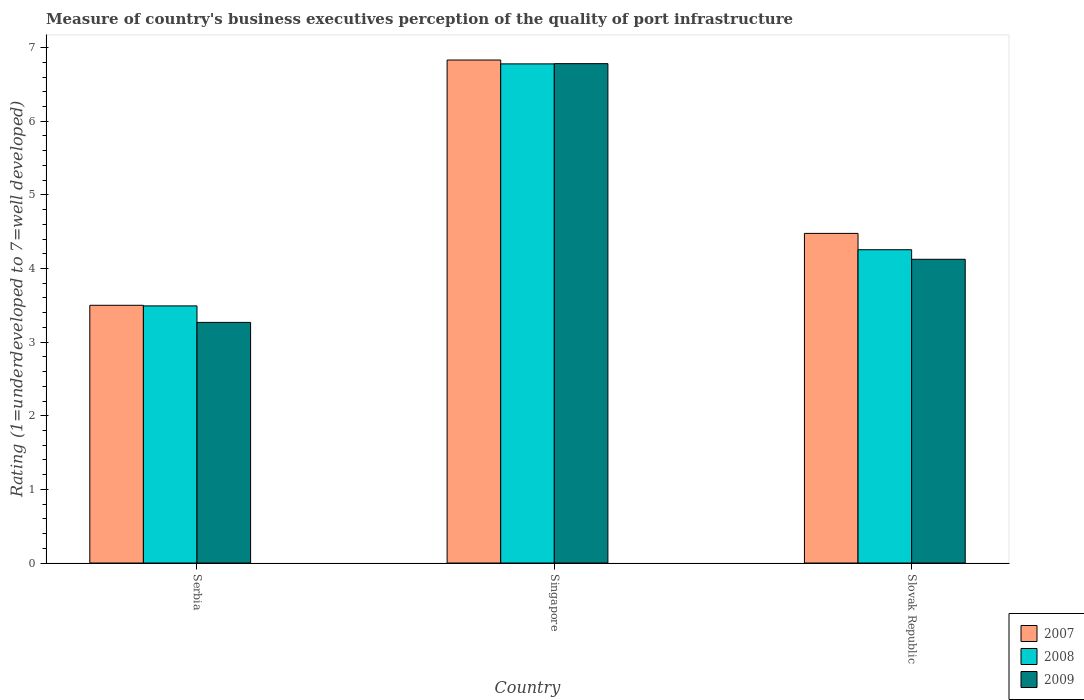How many different coloured bars are there?
Provide a succinct answer. 3. How many groups of bars are there?
Offer a very short reply. 3. Are the number of bars per tick equal to the number of legend labels?
Keep it short and to the point. Yes. Are the number of bars on each tick of the X-axis equal?
Your answer should be compact. Yes. How many bars are there on the 1st tick from the left?
Provide a succinct answer. 3. What is the label of the 2nd group of bars from the left?
Make the answer very short. Singapore. What is the ratings of the quality of port infrastructure in 2007 in Slovak Republic?
Offer a terse response. 4.48. Across all countries, what is the maximum ratings of the quality of port infrastructure in 2009?
Offer a terse response. 6.78. Across all countries, what is the minimum ratings of the quality of port infrastructure in 2009?
Offer a terse response. 3.27. In which country was the ratings of the quality of port infrastructure in 2007 maximum?
Your response must be concise. Singapore. In which country was the ratings of the quality of port infrastructure in 2009 minimum?
Your answer should be compact. Serbia. What is the total ratings of the quality of port infrastructure in 2007 in the graph?
Provide a succinct answer. 14.81. What is the difference between the ratings of the quality of port infrastructure in 2008 in Serbia and that in Singapore?
Ensure brevity in your answer.  -3.29. What is the difference between the ratings of the quality of port infrastructure in 2009 in Singapore and the ratings of the quality of port infrastructure in 2008 in Serbia?
Provide a succinct answer. 3.29. What is the average ratings of the quality of port infrastructure in 2007 per country?
Provide a succinct answer. 4.94. What is the difference between the ratings of the quality of port infrastructure of/in 2009 and ratings of the quality of port infrastructure of/in 2007 in Singapore?
Keep it short and to the point. -0.05. What is the ratio of the ratings of the quality of port infrastructure in 2009 in Serbia to that in Singapore?
Provide a short and direct response. 0.48. Is the difference between the ratings of the quality of port infrastructure in 2009 in Singapore and Slovak Republic greater than the difference between the ratings of the quality of port infrastructure in 2007 in Singapore and Slovak Republic?
Provide a short and direct response. Yes. What is the difference between the highest and the second highest ratings of the quality of port infrastructure in 2007?
Offer a terse response. -0.98. What is the difference between the highest and the lowest ratings of the quality of port infrastructure in 2009?
Offer a very short reply. 3.51. Is the sum of the ratings of the quality of port infrastructure in 2007 in Singapore and Slovak Republic greater than the maximum ratings of the quality of port infrastructure in 2008 across all countries?
Give a very brief answer. Yes. Is it the case that in every country, the sum of the ratings of the quality of port infrastructure in 2007 and ratings of the quality of port infrastructure in 2009 is greater than the ratings of the quality of port infrastructure in 2008?
Make the answer very short. Yes. How many bars are there?
Ensure brevity in your answer.  9. Are all the bars in the graph horizontal?
Your answer should be very brief. No. How many countries are there in the graph?
Your response must be concise. 3. What is the difference between two consecutive major ticks on the Y-axis?
Offer a very short reply. 1. Does the graph contain grids?
Offer a very short reply. No. How are the legend labels stacked?
Offer a terse response. Vertical. What is the title of the graph?
Offer a terse response. Measure of country's business executives perception of the quality of port infrastructure. What is the label or title of the Y-axis?
Make the answer very short. Rating (1=underdeveloped to 7=well developed). What is the Rating (1=underdeveloped to 7=well developed) of 2008 in Serbia?
Your answer should be very brief. 3.49. What is the Rating (1=underdeveloped to 7=well developed) of 2009 in Serbia?
Give a very brief answer. 3.27. What is the Rating (1=underdeveloped to 7=well developed) in 2007 in Singapore?
Provide a succinct answer. 6.83. What is the Rating (1=underdeveloped to 7=well developed) in 2008 in Singapore?
Keep it short and to the point. 6.78. What is the Rating (1=underdeveloped to 7=well developed) of 2009 in Singapore?
Make the answer very short. 6.78. What is the Rating (1=underdeveloped to 7=well developed) of 2007 in Slovak Republic?
Your response must be concise. 4.48. What is the Rating (1=underdeveloped to 7=well developed) of 2008 in Slovak Republic?
Make the answer very short. 4.25. What is the Rating (1=underdeveloped to 7=well developed) of 2009 in Slovak Republic?
Ensure brevity in your answer.  4.12. Across all countries, what is the maximum Rating (1=underdeveloped to 7=well developed) in 2007?
Offer a terse response. 6.83. Across all countries, what is the maximum Rating (1=underdeveloped to 7=well developed) of 2008?
Provide a succinct answer. 6.78. Across all countries, what is the maximum Rating (1=underdeveloped to 7=well developed) of 2009?
Your answer should be compact. 6.78. Across all countries, what is the minimum Rating (1=underdeveloped to 7=well developed) of 2007?
Give a very brief answer. 3.5. Across all countries, what is the minimum Rating (1=underdeveloped to 7=well developed) of 2008?
Provide a short and direct response. 3.49. Across all countries, what is the minimum Rating (1=underdeveloped to 7=well developed) of 2009?
Provide a short and direct response. 3.27. What is the total Rating (1=underdeveloped to 7=well developed) of 2007 in the graph?
Your answer should be compact. 14.81. What is the total Rating (1=underdeveloped to 7=well developed) in 2008 in the graph?
Your response must be concise. 14.52. What is the total Rating (1=underdeveloped to 7=well developed) of 2009 in the graph?
Offer a terse response. 14.17. What is the difference between the Rating (1=underdeveloped to 7=well developed) of 2007 in Serbia and that in Singapore?
Your response must be concise. -3.33. What is the difference between the Rating (1=underdeveloped to 7=well developed) of 2008 in Serbia and that in Singapore?
Offer a terse response. -3.29. What is the difference between the Rating (1=underdeveloped to 7=well developed) of 2009 in Serbia and that in Singapore?
Offer a terse response. -3.51. What is the difference between the Rating (1=underdeveloped to 7=well developed) in 2007 in Serbia and that in Slovak Republic?
Make the answer very short. -0.98. What is the difference between the Rating (1=underdeveloped to 7=well developed) of 2008 in Serbia and that in Slovak Republic?
Your response must be concise. -0.76. What is the difference between the Rating (1=underdeveloped to 7=well developed) of 2009 in Serbia and that in Slovak Republic?
Provide a short and direct response. -0.86. What is the difference between the Rating (1=underdeveloped to 7=well developed) in 2007 in Singapore and that in Slovak Republic?
Your response must be concise. 2.35. What is the difference between the Rating (1=underdeveloped to 7=well developed) of 2008 in Singapore and that in Slovak Republic?
Offer a very short reply. 2.52. What is the difference between the Rating (1=underdeveloped to 7=well developed) of 2009 in Singapore and that in Slovak Republic?
Your answer should be compact. 2.66. What is the difference between the Rating (1=underdeveloped to 7=well developed) in 2007 in Serbia and the Rating (1=underdeveloped to 7=well developed) in 2008 in Singapore?
Provide a short and direct response. -3.28. What is the difference between the Rating (1=underdeveloped to 7=well developed) in 2007 in Serbia and the Rating (1=underdeveloped to 7=well developed) in 2009 in Singapore?
Offer a very short reply. -3.28. What is the difference between the Rating (1=underdeveloped to 7=well developed) of 2008 in Serbia and the Rating (1=underdeveloped to 7=well developed) of 2009 in Singapore?
Provide a short and direct response. -3.29. What is the difference between the Rating (1=underdeveloped to 7=well developed) in 2007 in Serbia and the Rating (1=underdeveloped to 7=well developed) in 2008 in Slovak Republic?
Offer a terse response. -0.75. What is the difference between the Rating (1=underdeveloped to 7=well developed) of 2007 in Serbia and the Rating (1=underdeveloped to 7=well developed) of 2009 in Slovak Republic?
Provide a short and direct response. -0.62. What is the difference between the Rating (1=underdeveloped to 7=well developed) in 2008 in Serbia and the Rating (1=underdeveloped to 7=well developed) in 2009 in Slovak Republic?
Your response must be concise. -0.63. What is the difference between the Rating (1=underdeveloped to 7=well developed) of 2007 in Singapore and the Rating (1=underdeveloped to 7=well developed) of 2008 in Slovak Republic?
Offer a terse response. 2.58. What is the difference between the Rating (1=underdeveloped to 7=well developed) in 2007 in Singapore and the Rating (1=underdeveloped to 7=well developed) in 2009 in Slovak Republic?
Offer a terse response. 2.71. What is the difference between the Rating (1=underdeveloped to 7=well developed) in 2008 in Singapore and the Rating (1=underdeveloped to 7=well developed) in 2009 in Slovak Republic?
Make the answer very short. 2.65. What is the average Rating (1=underdeveloped to 7=well developed) of 2007 per country?
Offer a terse response. 4.94. What is the average Rating (1=underdeveloped to 7=well developed) of 2008 per country?
Make the answer very short. 4.84. What is the average Rating (1=underdeveloped to 7=well developed) of 2009 per country?
Give a very brief answer. 4.72. What is the difference between the Rating (1=underdeveloped to 7=well developed) in 2007 and Rating (1=underdeveloped to 7=well developed) in 2008 in Serbia?
Offer a terse response. 0.01. What is the difference between the Rating (1=underdeveloped to 7=well developed) of 2007 and Rating (1=underdeveloped to 7=well developed) of 2009 in Serbia?
Provide a short and direct response. 0.23. What is the difference between the Rating (1=underdeveloped to 7=well developed) of 2008 and Rating (1=underdeveloped to 7=well developed) of 2009 in Serbia?
Ensure brevity in your answer.  0.22. What is the difference between the Rating (1=underdeveloped to 7=well developed) in 2007 and Rating (1=underdeveloped to 7=well developed) in 2008 in Singapore?
Provide a short and direct response. 0.05. What is the difference between the Rating (1=underdeveloped to 7=well developed) of 2007 and Rating (1=underdeveloped to 7=well developed) of 2009 in Singapore?
Provide a succinct answer. 0.05. What is the difference between the Rating (1=underdeveloped to 7=well developed) in 2008 and Rating (1=underdeveloped to 7=well developed) in 2009 in Singapore?
Your response must be concise. -0. What is the difference between the Rating (1=underdeveloped to 7=well developed) of 2007 and Rating (1=underdeveloped to 7=well developed) of 2008 in Slovak Republic?
Offer a very short reply. 0.22. What is the difference between the Rating (1=underdeveloped to 7=well developed) of 2007 and Rating (1=underdeveloped to 7=well developed) of 2009 in Slovak Republic?
Your answer should be compact. 0.35. What is the difference between the Rating (1=underdeveloped to 7=well developed) in 2008 and Rating (1=underdeveloped to 7=well developed) in 2009 in Slovak Republic?
Your answer should be compact. 0.13. What is the ratio of the Rating (1=underdeveloped to 7=well developed) in 2007 in Serbia to that in Singapore?
Keep it short and to the point. 0.51. What is the ratio of the Rating (1=underdeveloped to 7=well developed) of 2008 in Serbia to that in Singapore?
Offer a very short reply. 0.52. What is the ratio of the Rating (1=underdeveloped to 7=well developed) of 2009 in Serbia to that in Singapore?
Your response must be concise. 0.48. What is the ratio of the Rating (1=underdeveloped to 7=well developed) in 2007 in Serbia to that in Slovak Republic?
Make the answer very short. 0.78. What is the ratio of the Rating (1=underdeveloped to 7=well developed) of 2008 in Serbia to that in Slovak Republic?
Make the answer very short. 0.82. What is the ratio of the Rating (1=underdeveloped to 7=well developed) of 2009 in Serbia to that in Slovak Republic?
Offer a very short reply. 0.79. What is the ratio of the Rating (1=underdeveloped to 7=well developed) of 2007 in Singapore to that in Slovak Republic?
Ensure brevity in your answer.  1.53. What is the ratio of the Rating (1=underdeveloped to 7=well developed) in 2008 in Singapore to that in Slovak Republic?
Provide a short and direct response. 1.59. What is the ratio of the Rating (1=underdeveloped to 7=well developed) in 2009 in Singapore to that in Slovak Republic?
Keep it short and to the point. 1.64. What is the difference between the highest and the second highest Rating (1=underdeveloped to 7=well developed) of 2007?
Provide a short and direct response. 2.35. What is the difference between the highest and the second highest Rating (1=underdeveloped to 7=well developed) of 2008?
Give a very brief answer. 2.52. What is the difference between the highest and the second highest Rating (1=underdeveloped to 7=well developed) of 2009?
Provide a short and direct response. 2.66. What is the difference between the highest and the lowest Rating (1=underdeveloped to 7=well developed) of 2007?
Your answer should be compact. 3.33. What is the difference between the highest and the lowest Rating (1=underdeveloped to 7=well developed) of 2008?
Your response must be concise. 3.29. What is the difference between the highest and the lowest Rating (1=underdeveloped to 7=well developed) in 2009?
Offer a terse response. 3.51. 